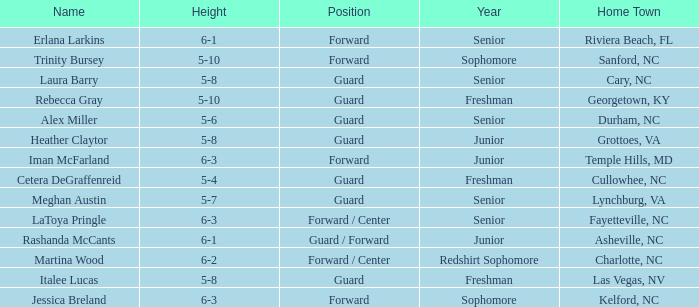In what school year is the athlete from fayetteville, nc? Senior. 